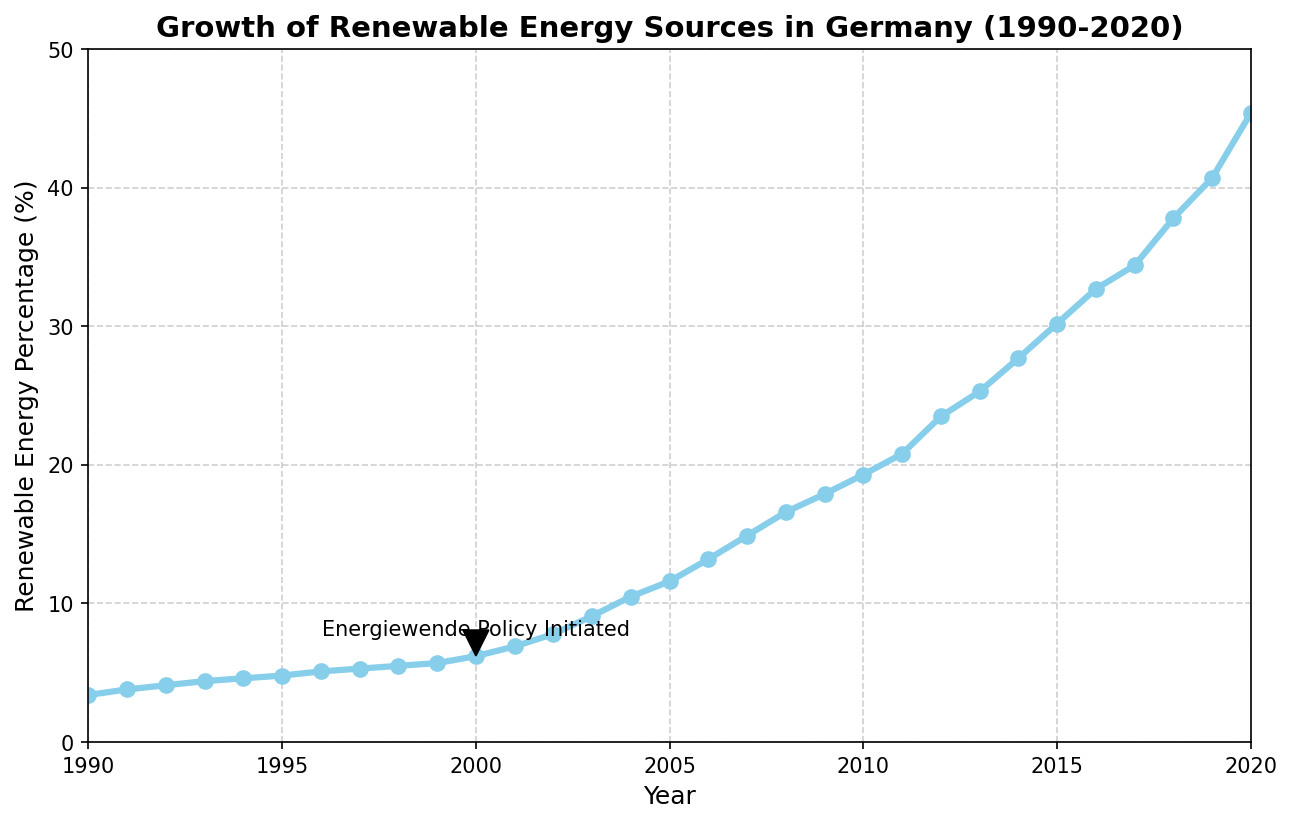What was the renewable energy percentage in the year 2000? The year 2000 is highlighted with an annotation and shows a data point on the line representing the Renewable Energy Percentage. Looking at this specific data point indicates the percentage.
Answer: 6.2% Between what years did the renewable energy percentage more than double for the first time? Look for the span of years where the renewable energy percentage is first doubled. The percentage in 1990 was 3.4%; doubling it would be 6.8. This occurs sometime after 2000 when the percentage surpasses 6.8.
Answer: 1990 to 2001 What is the difference in the renewable energy percentage between 2000 and 2020? Subtract the percentage value in 2000 (6.2%) from the value in 2020 (45.4%) to find the difference.
Answer: 39.2% Which year marked the initiation of the Energiewende policy according to the plot? There is a specific annotation in the plot indicating the initiation of the Energiewende policy.
Answer: 2000 How many years did it take for the renewable energy percentage to surpass 20% after the Energiewende policy initiation? Identify the year the policy was initiated (2000) and find the first year when the renewable energy percentage surpasses 20% (2010), then calculate the difference in years.
Answer: 10 years By what percentage did renewable energy increase from 1990 to 2000? Subtract the renewable energy percentage in 1990 from that in 2000 (6.2% - 3.4%) to get the increase in percentage points, then compare it relative to the initial value in 1990.
Answer: 2.8 percentage points In which year did the renewable energy percentage first exceed 30%? Locate the first year in the graph where the renewable energy percentage is greater than 30%.
Answer: 2015 Compare the growth rate of renewable energy from 1990 to 2000 to the growth rate from 2000 to 2010. Which period had a higher rate of increase? Calculate the renewable energy percentage increase for each period (3.4% to 6.2% for 1990-2000, 6.2% to 19.3% for 2000-2010) and determine which period had the higher increase.
Answer: 2000 to 2010 How many years after 2000 did it take for renewable energy to reach 20%? Identify the exact year when the renewable energy percentage reached 20%, count the number of years from 2000 to that year (2011).
Answer: 11 years What was the renewable energy percentage in 2010, and how does it compare to 2000? Find the percentage in 2010 and 2000. Compare the two values by calculating the difference (19.3% in 2010 and 6.2% in 2000).
Answer: 19.3%, which is 13.1% higher than in 2000 